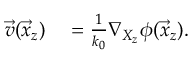Convert formula to latex. <formula><loc_0><loc_0><loc_500><loc_500>\begin{array} { r l } { \vec { v } ( \vec { x } _ { z } ) } & = \frac { 1 } { k _ { 0 } } \nabla _ { X _ { z } } \phi ( \vec { x } _ { z } ) . } \end{array}</formula> 